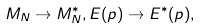Convert formula to latex. <formula><loc_0><loc_0><loc_500><loc_500>M _ { N } \rightarrow M ^ { \ast } _ { N } , E ( p ) \rightarrow E ^ { \ast } ( p ) ,</formula> 